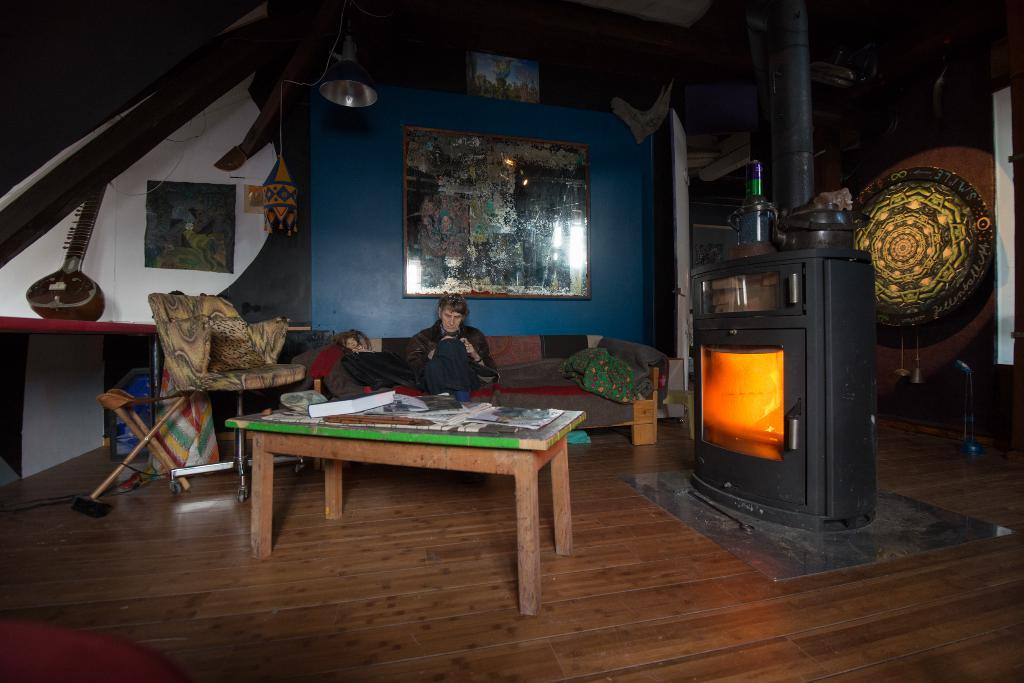What is located in the middle of the image? There is a table in the middle of the image. What is on the table? There is a book on the table. What can be seen on the right side of the image? There is a fireplace on the right side of the image. Where is the man sitting in the image? The man is sitting on a sofa near the fireplace. What is behind the man? There is a wall behind the man. How many deer are visible in the image? There are no deer present in the image. What color is the balloon that the man is holding in the image? There is no balloon present in the image. 